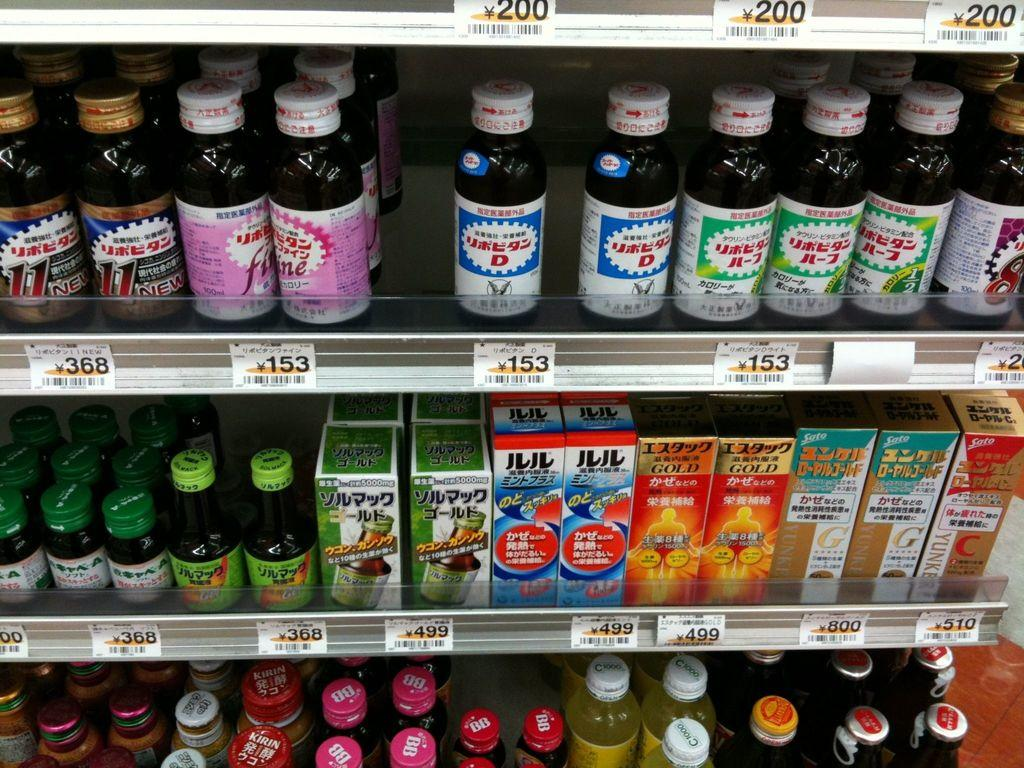What types of objects are visible in the image? There are bottles and boxes in the image. How are the bottles and boxes arranged? The bottles and boxes are arranged in a rack. Are there different types of bottles present? Yes, different kinds of bottles are present. What additional information can be seen in front of the bottles? Different numbers are visible in front of the bottles. What type of wool is being used to create the sign in the image? There is no wool or sign present in the image. 